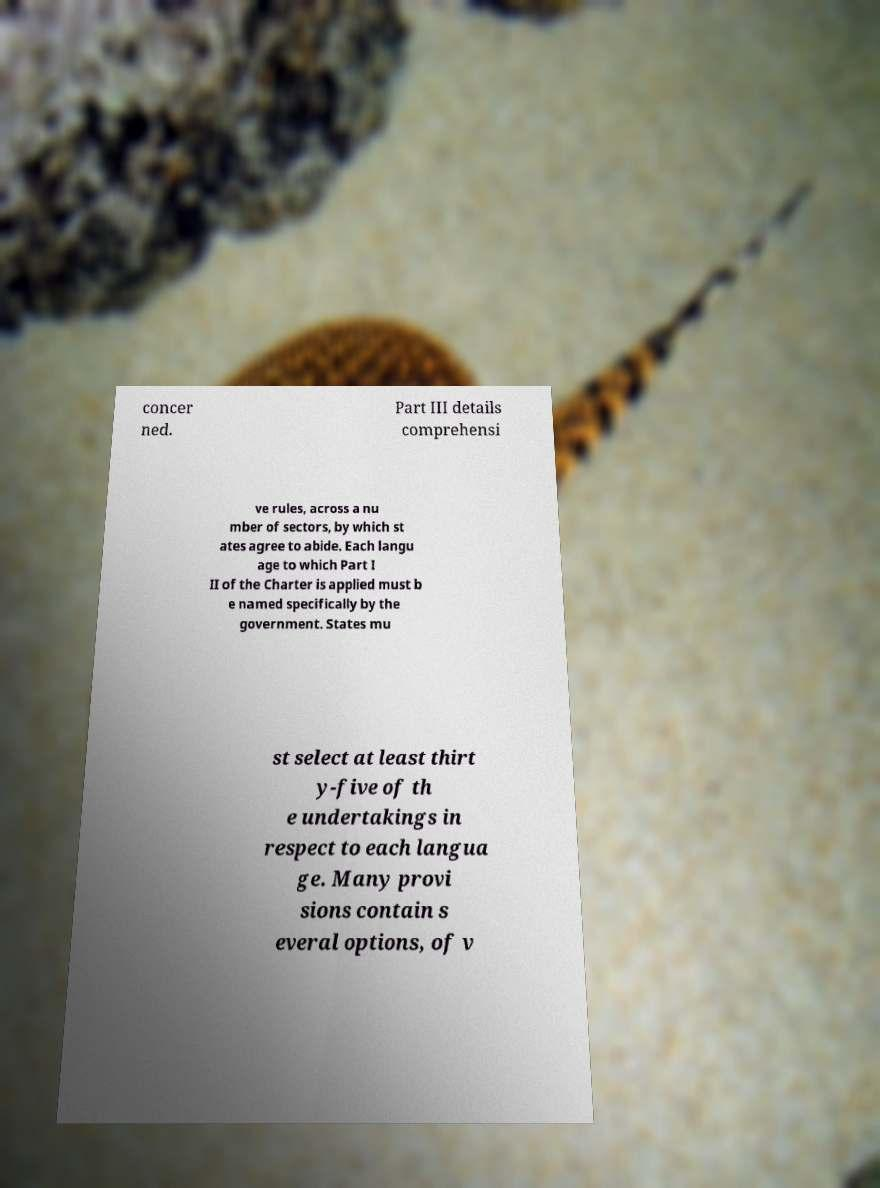For documentation purposes, I need the text within this image transcribed. Could you provide that? concer ned. Part III details comprehensi ve rules, across a nu mber of sectors, by which st ates agree to abide. Each langu age to which Part I II of the Charter is applied must b e named specifically by the government. States mu st select at least thirt y-five of th e undertakings in respect to each langua ge. Many provi sions contain s everal options, of v 